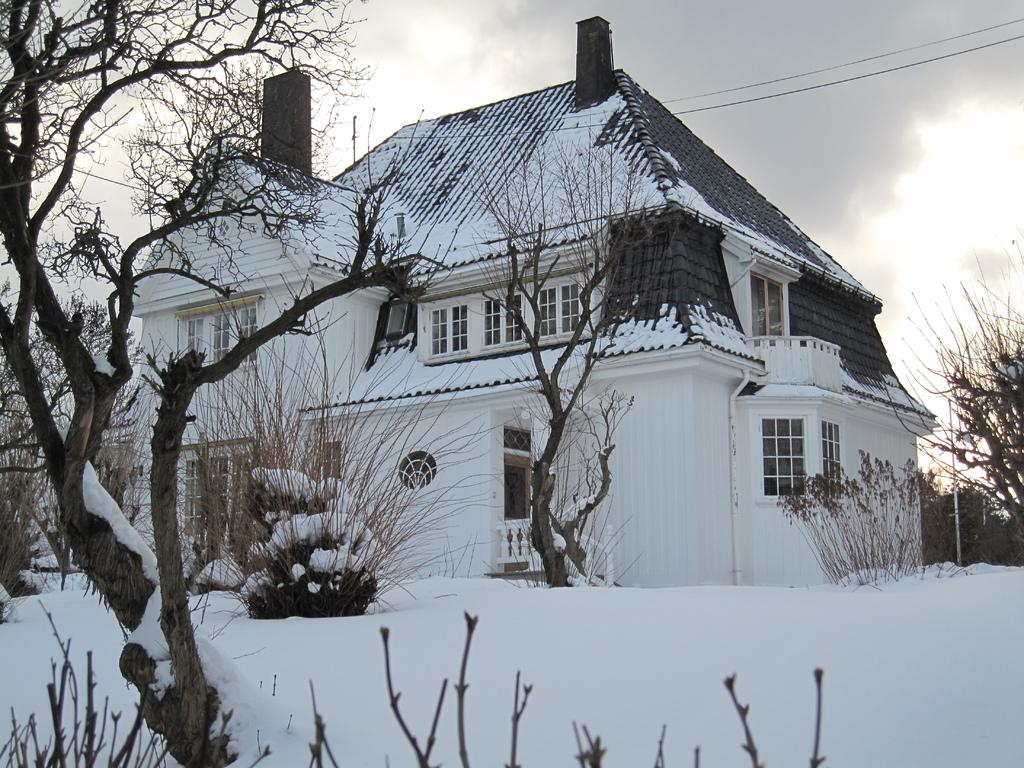What is covering the plants, trees, and ground in the image? There is snow on the plants, trees, and ground in the image. What type of structure can be seen in the image? There is a building in the image. What feature of the building is visible? There are windows visible on the building. What else can be seen in the image besides the snow and building? Electric wires and a pole are present in the image. What is visible in the sky in the image? Clouds are visible in the sky. What word is written on the pan in the image? There is no pan present in the image, so it is not possible to answer that question. 